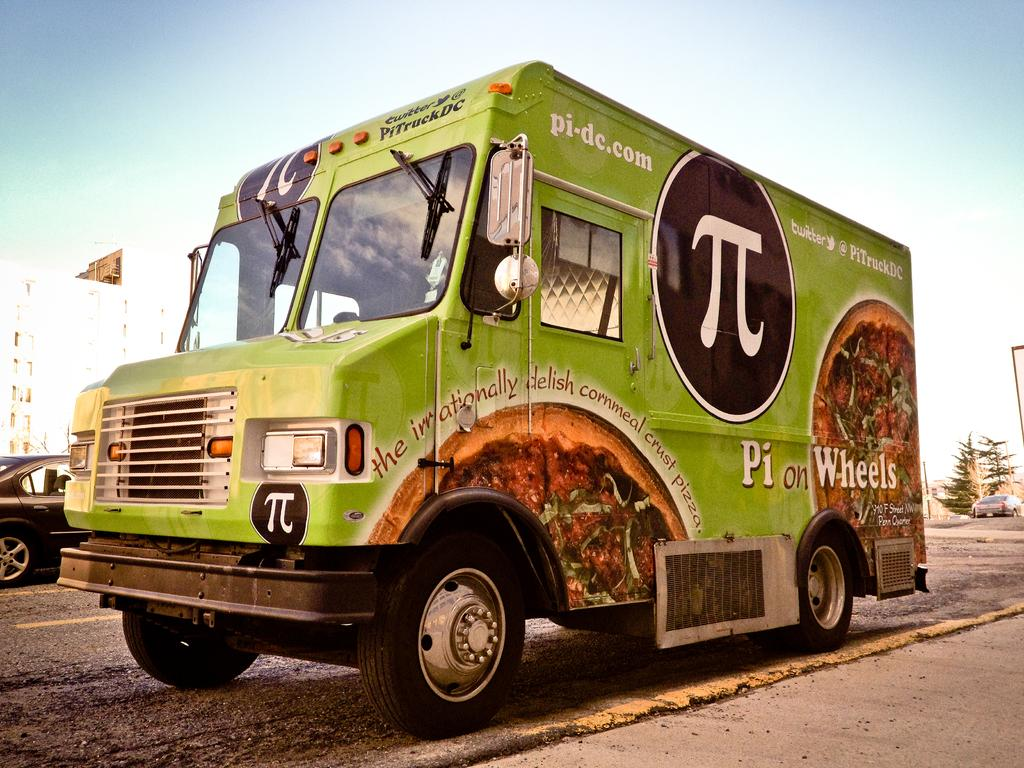What can be seen on the road in the image? There are vehicles on the road in the image. What is visible in the background of the image? There are buildings, trees, and the sky visible in the background of the image. Where is the flag located in the image? The flag is on the left side of the image. What type of meat is being cooked in the bucket in the image? There is no meat or bucket present in the image. What flavor of jam can be seen on the trees in the image? There is no jam present in the image; it features trees in the background. 